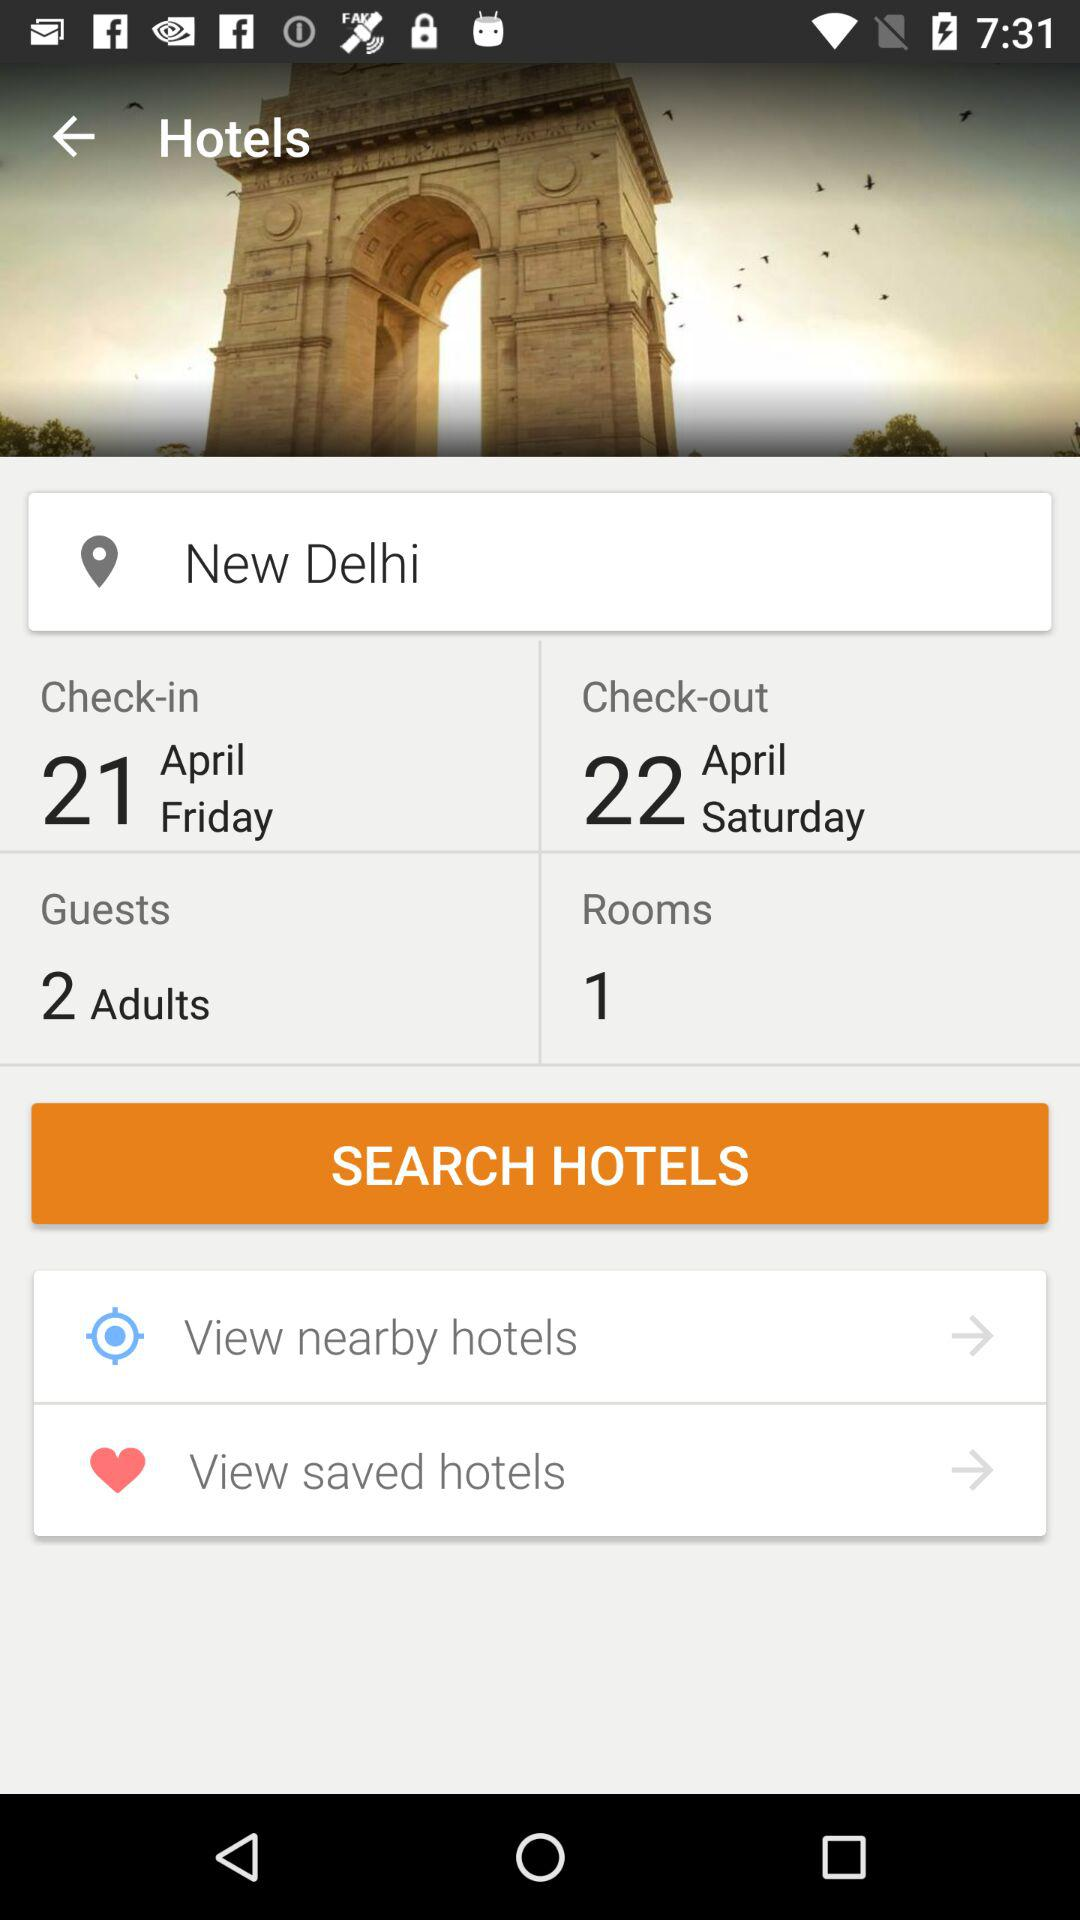What is the check-in date? The check-in date is Friday, April 21. 